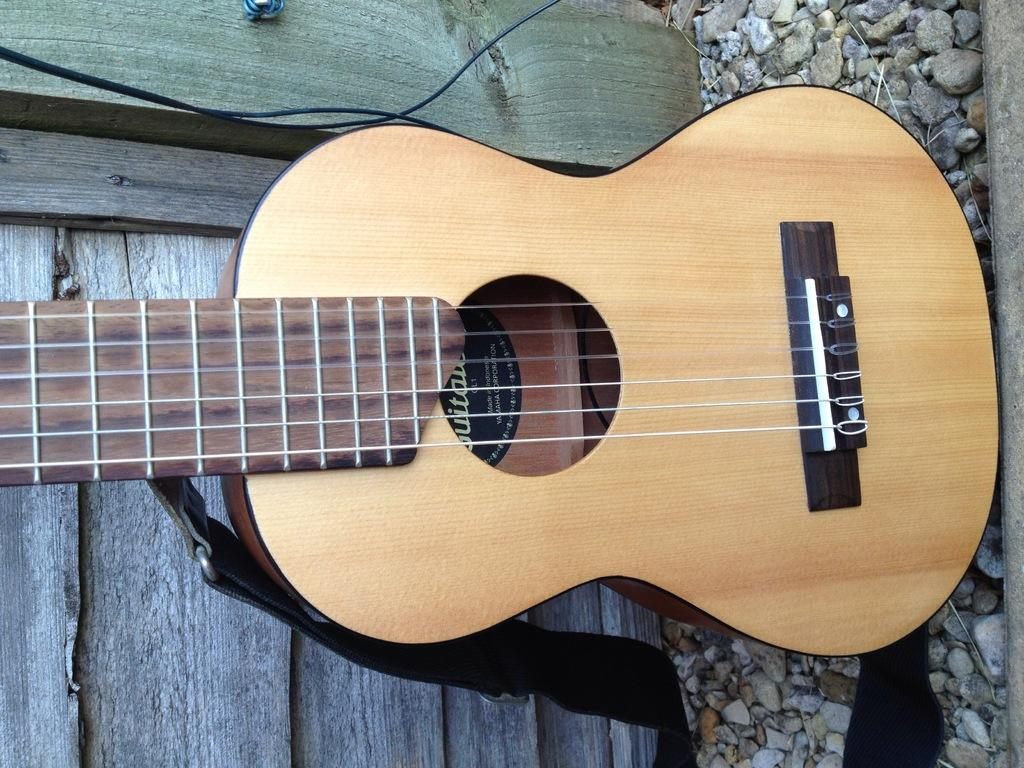What musical instrument is present in the image? There is a guitar in the image. What type of objects can be seen besides the guitar? There are stones in the image. What type of ear is visible in the image? There is no ear present in the image. Where is the meeting taking place in the image? There is no meeting depicted in the image. 